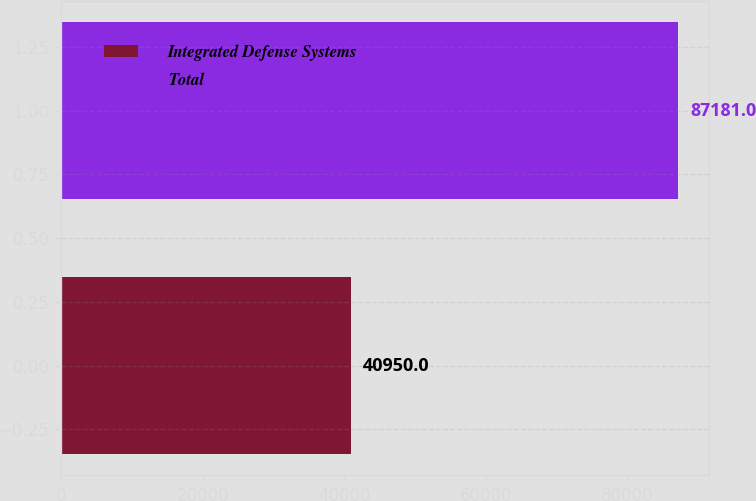Convert chart. <chart><loc_0><loc_0><loc_500><loc_500><bar_chart><fcel>Integrated Defense Systems<fcel>Total<nl><fcel>40950<fcel>87181<nl></chart> 